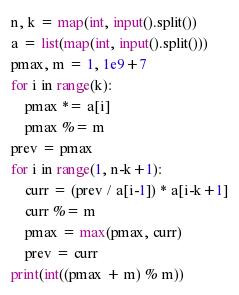Convert code to text. <code><loc_0><loc_0><loc_500><loc_500><_Python_>n, k = map(int, input().split())
a = list(map(int, input().split()))
pmax, m = 1, 1e9+7
for i in range(k):
    pmax *= a[i]
    pmax %= m
prev = pmax
for i in range(1, n-k+1):
    curr = (prev / a[i-1]) * a[i-k+1]
    curr %= m
    pmax = max(pmax, curr)
    prev = curr
print(int((pmax + m) % m))</code> 